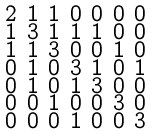<formula> <loc_0><loc_0><loc_500><loc_500>\begin{smallmatrix} 2 & 1 & 1 & 0 & 0 & 0 & 0 \\ 1 & 3 & 1 & 1 & 1 & 0 & 0 \\ 1 & 1 & 3 & 0 & 0 & 1 & 0 \\ 0 & 1 & 0 & 3 & 1 & 0 & 1 \\ 0 & 1 & 0 & 1 & 3 & 0 & 0 \\ 0 & 0 & 1 & 0 & 0 & 3 & 0 \\ 0 & 0 & 0 & 1 & 0 & 0 & 3 \end{smallmatrix}</formula> 